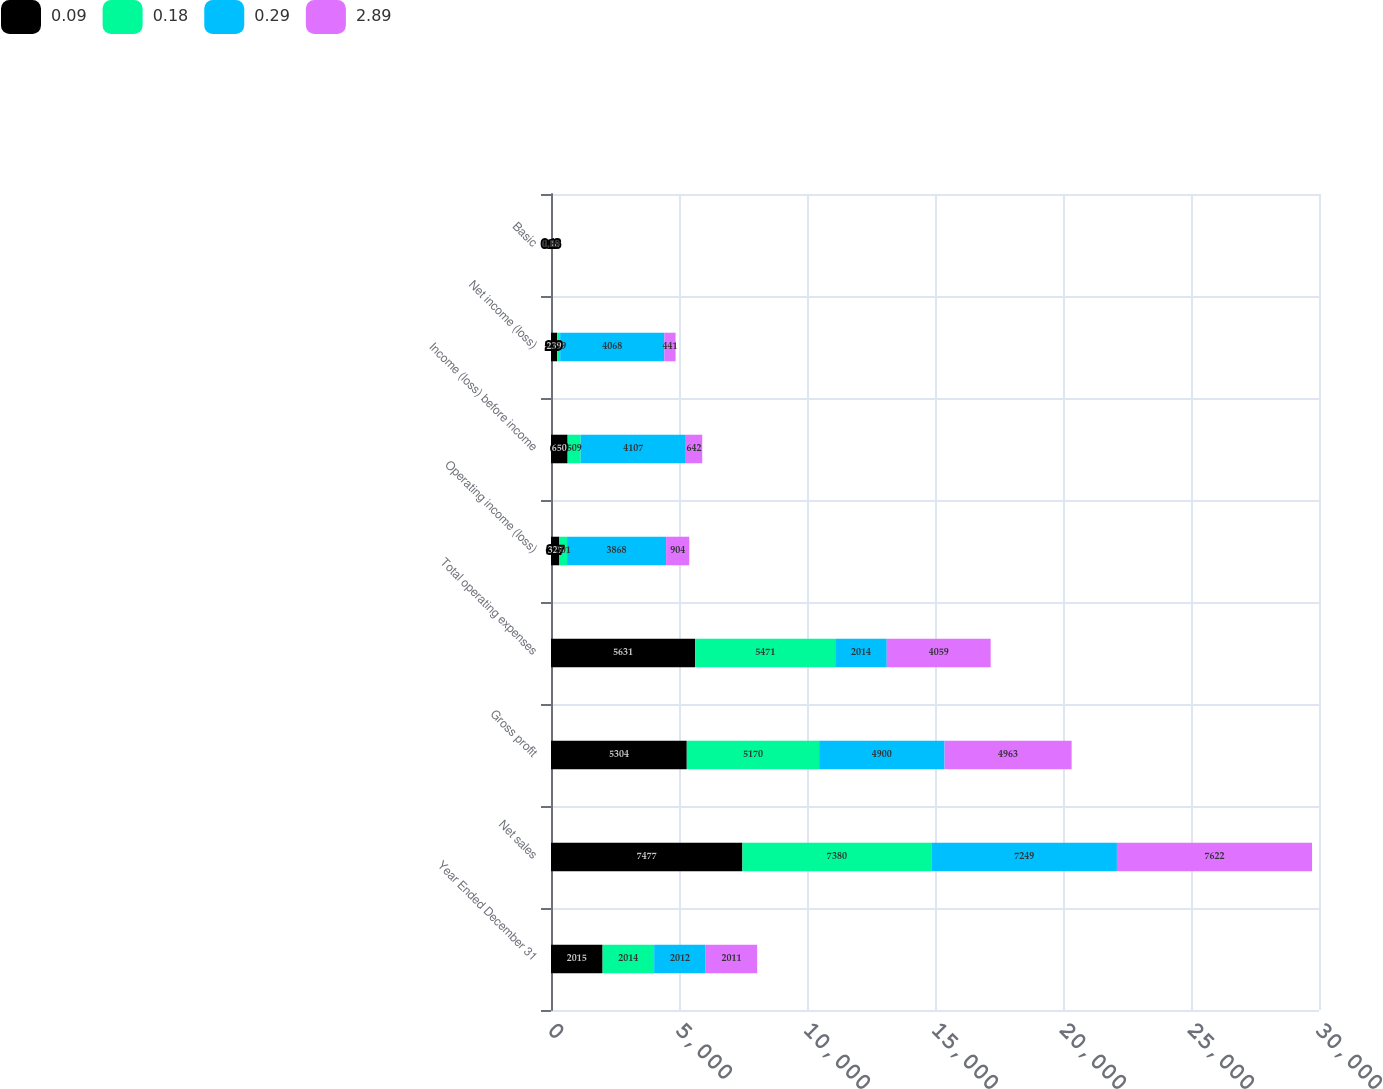Convert chart to OTSL. <chart><loc_0><loc_0><loc_500><loc_500><stacked_bar_chart><ecel><fcel>Year Ended December 31<fcel>Net sales<fcel>Gross profit<fcel>Total operating expenses<fcel>Operating income (loss)<fcel>Income (loss) before income<fcel>Net income (loss)<fcel>Basic<nl><fcel>0.09<fcel>2015<fcel>7477<fcel>5304<fcel>5631<fcel>327<fcel>650<fcel>239<fcel>0.18<nl><fcel>0.18<fcel>2014<fcel>7380<fcel>5170<fcel>5471<fcel>301<fcel>509<fcel>119<fcel>0.09<nl><fcel>0.29<fcel>2012<fcel>7249<fcel>4900<fcel>2014<fcel>3868<fcel>4107<fcel>4068<fcel>2.89<nl><fcel>2.89<fcel>2011<fcel>7622<fcel>4963<fcel>4059<fcel>904<fcel>642<fcel>441<fcel>0.29<nl></chart> 